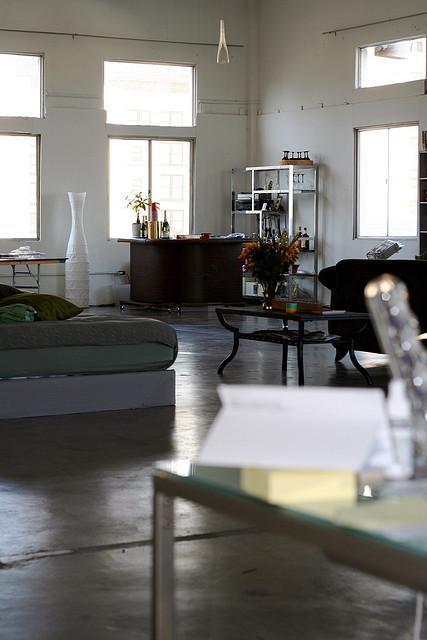How many vases are there?
Give a very brief answer. 1. 